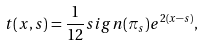<formula> <loc_0><loc_0><loc_500><loc_500>t ( x , s ) = { \frac { 1 } { 1 2 } } s i g n ( \pi _ { s } ) e ^ { 2 ( x - s ) } ,</formula> 